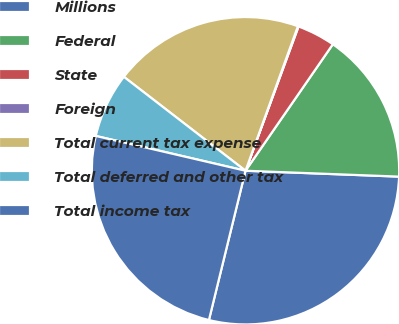Convert chart to OTSL. <chart><loc_0><loc_0><loc_500><loc_500><pie_chart><fcel>Millions<fcel>Federal<fcel>State<fcel>Foreign<fcel>Total current tax expense<fcel>Total deferred and other tax<fcel>Total income tax<nl><fcel>28.21%<fcel>15.99%<fcel>4.01%<fcel>0.07%<fcel>20.07%<fcel>6.83%<fcel>24.81%<nl></chart> 